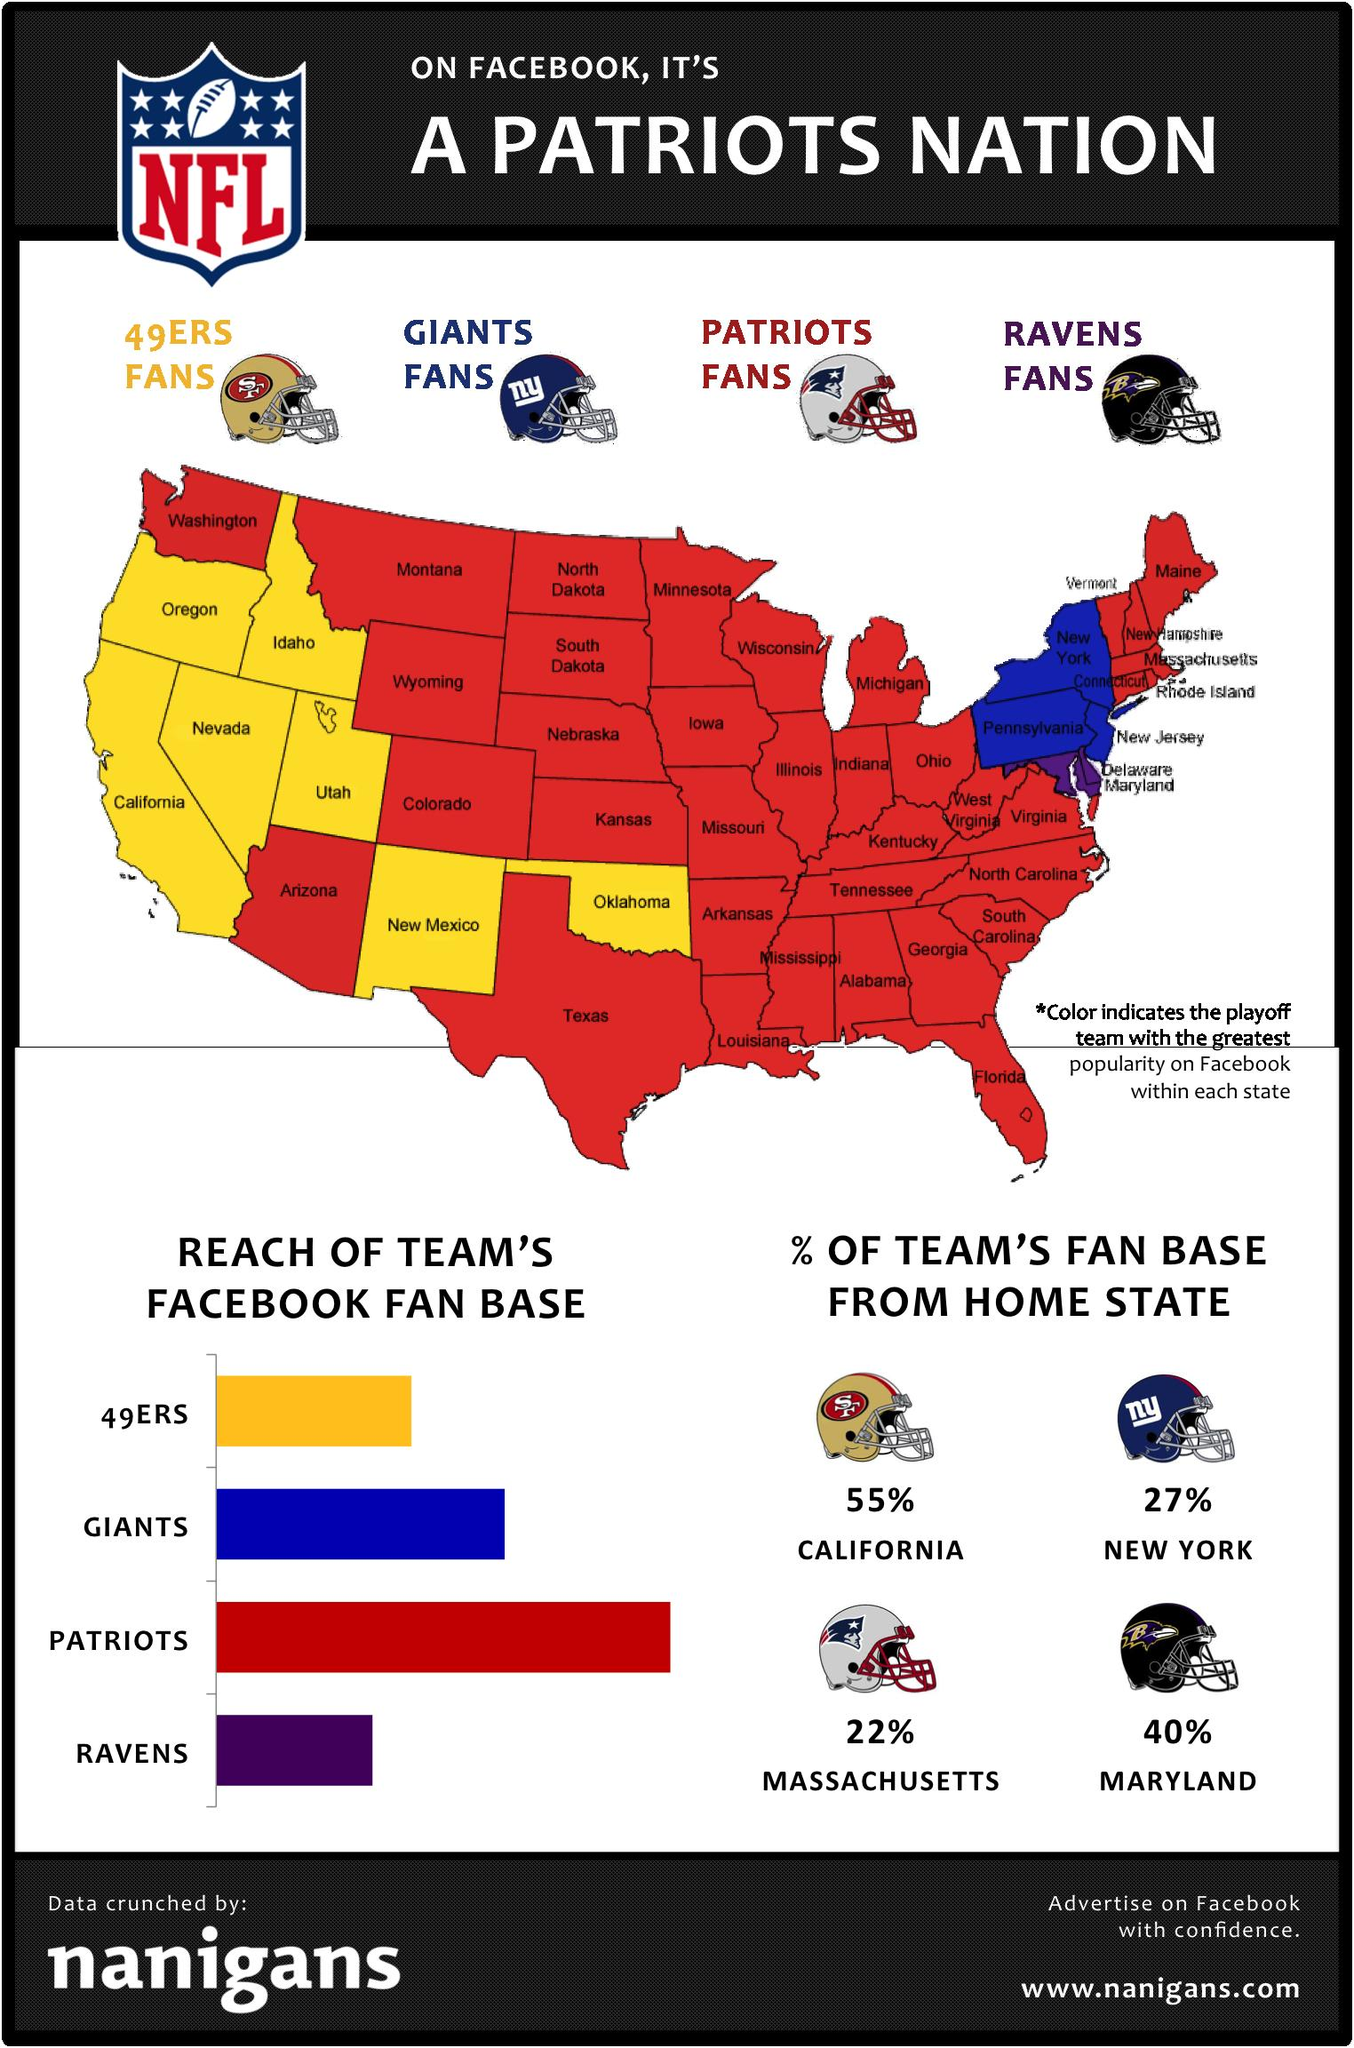List a handful of essential elements in this visual. The Ravens team's home state is Maryland. Red covers a significant portion of the map. The San Francisco 49ers are the team that has California as its home state. The Giants' Facebook fan base has the second highest reach, surpassed only by the team with the highest reach. The team with a fan base of 22% in its home state is the Patriots. 